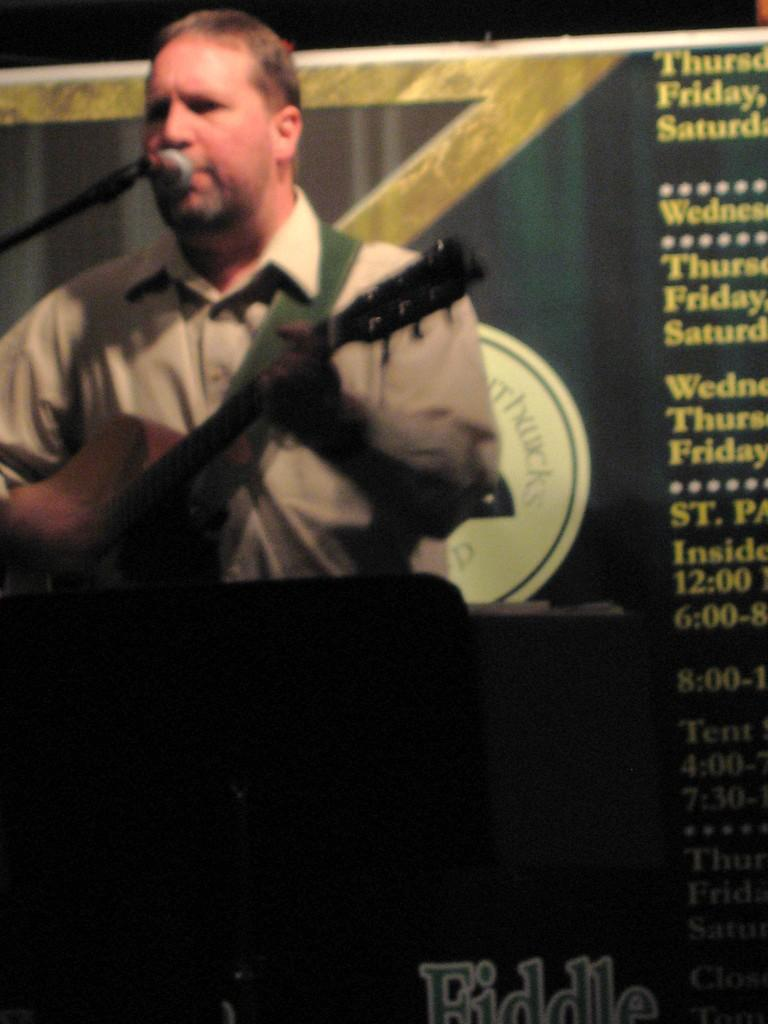What is the man in the image holding? The man is holding a guitar. What is the man positioned in front of in the image? The man is in front of a mic. What can be seen in the background of the image? There is a board in the background of the image. What is the man wearing in the image? The man is wearing a shirt. What type of holiday is the man celebrating in the image? There is no indication of a holiday in the image; it simply shows a man holding a guitar and standing in front of a mic. Does the existence of the board in the background of the image imply anything about the man's beliefs or values? The presence of the board in the background does not provide any information about the man's beliefs or values; it is simply a background element. 